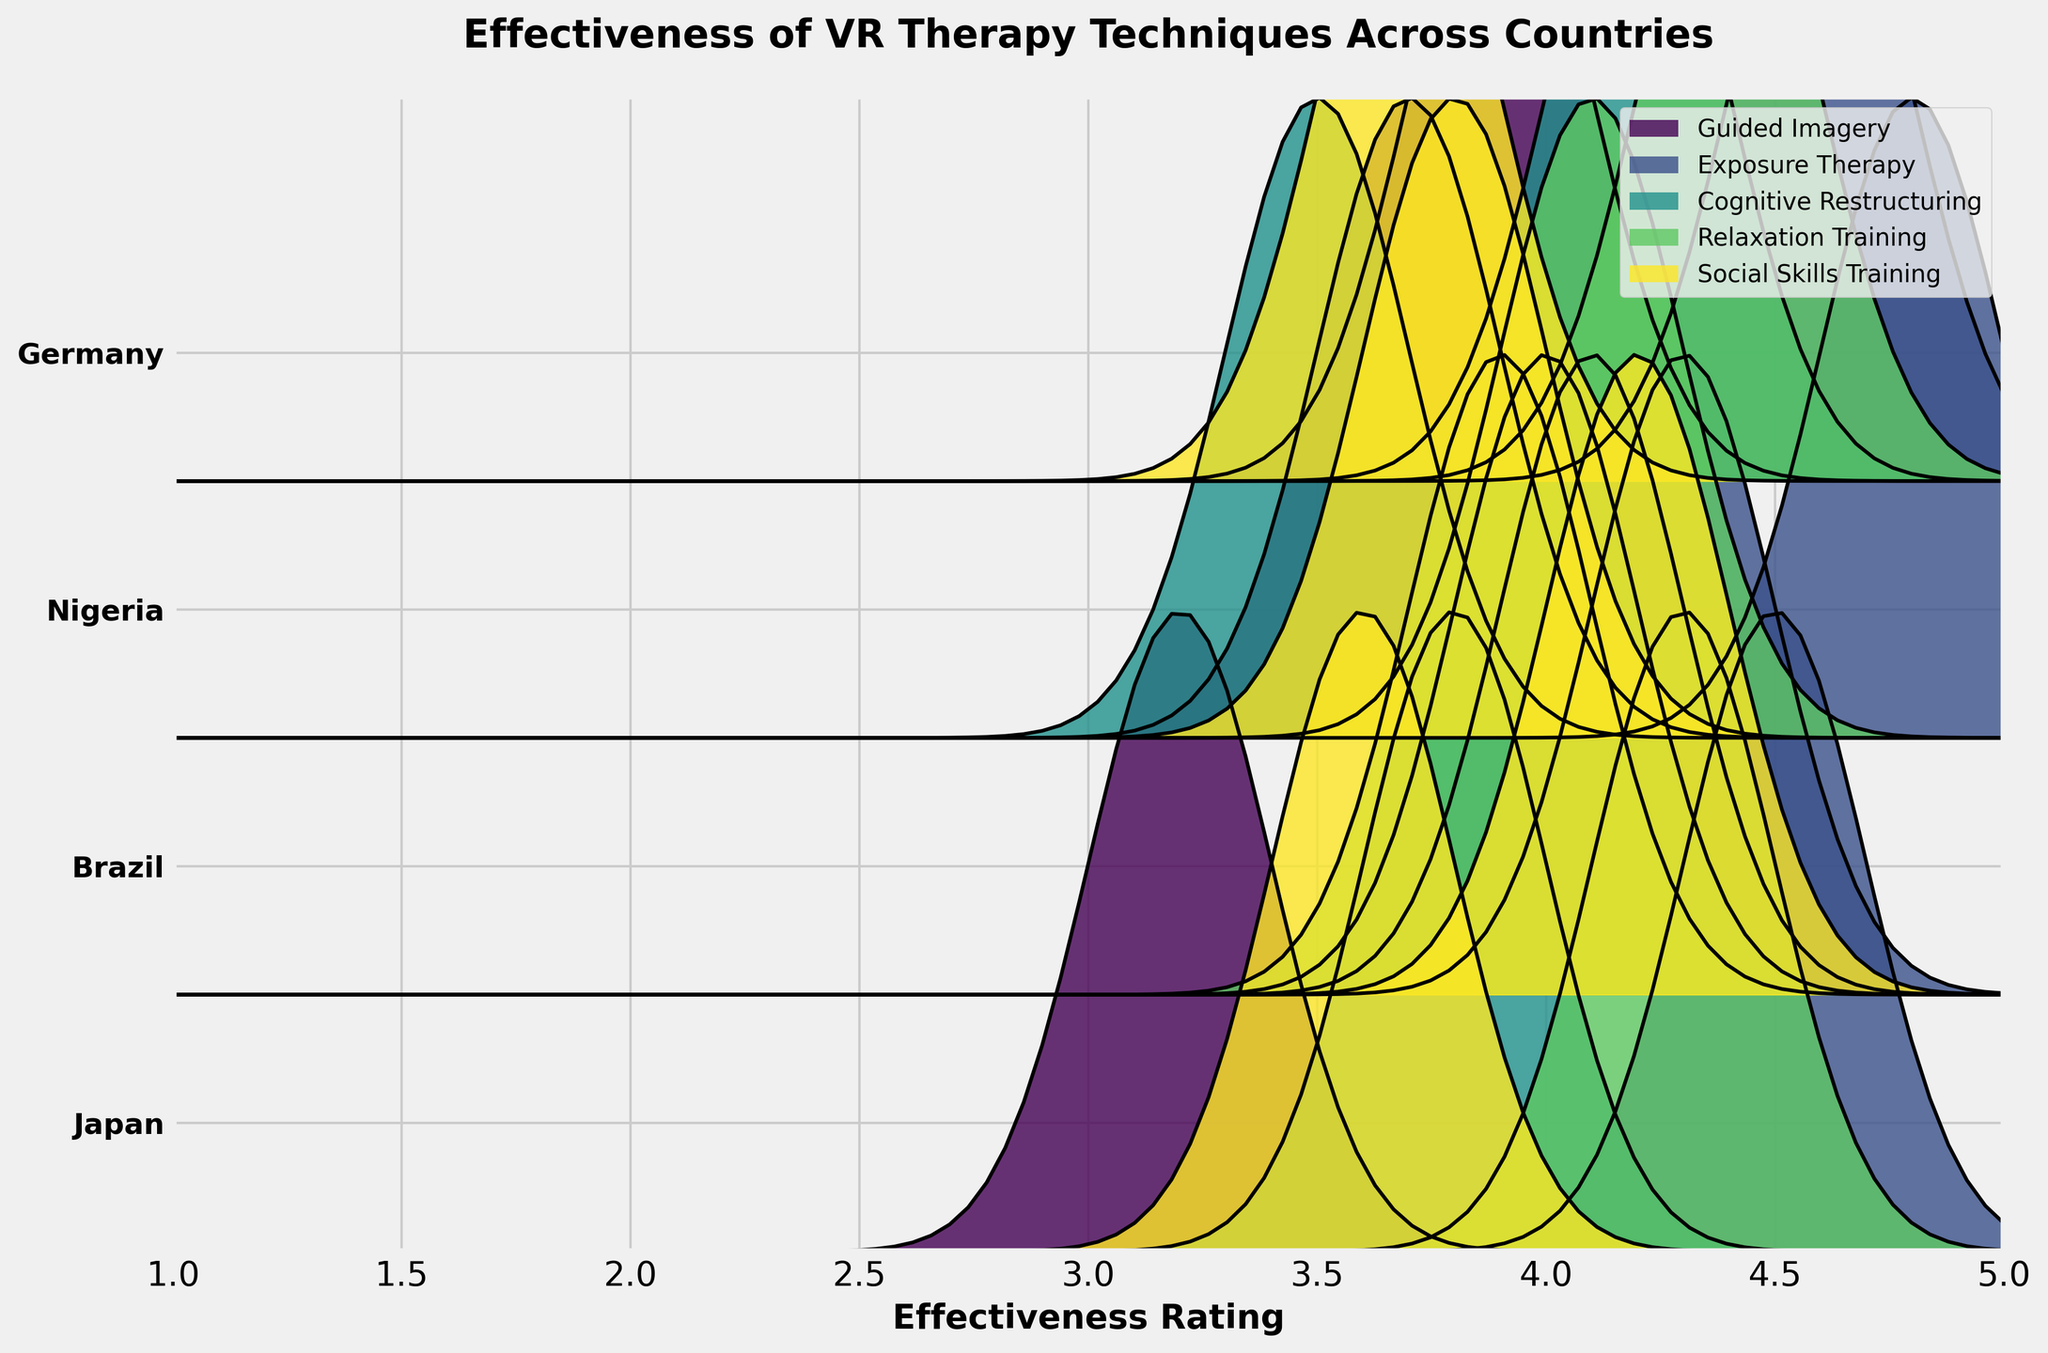What is the title of the plot? The title is always found at the top of the figure. Here, it is clearly visible in bold text.
Answer: Effectiveness of VR Therapy Techniques Across Countries What is the x-axis representing? The labels and title along the horizontal axis indicate what is being measured. Here, it says 'Effectiveness Rating'.
Answer: Effectiveness Rating How many VR therapy techniques are compared in the plot? Techniques can be identified by their unique fill colors and labels in the legend. Counting the legend entries gives us the number of techniques.
Answer: 5 Which country has the highest effectiveness rating for Exposure Therapy? Identify the curve labeled 'Exposure Therapy' and find the country corresponding to the highest peak.
Answer: Nigeria What is the effectiveness rating of Relaxation Training in Germany? Look for the curve labeled 'Relaxation Training' and identify the peak near the Germany label.
Answer: 4.4 Which VR therapy technique has the lowest effectiveness rating in Japan? Look through the curves aligned with Japan and find the one with the lowest peak value compared to the x-axis scale.
Answer: Guided Imagery What is the average effectiveness rating of Exposure Therapy across all countries? The effectiveness ratings for Exposure Therapy in different countries are 4.5, 4.3, 4.8, and 4.6. Add them together and divide by 4.
Answer: 4.55 Compare the effectiveness rating of Cognitive Restructuring between Brazil and Nigeria. Which country has a higher rating? Observe the Cognitive Restructuring curves aligned with Brazil and Nigeria, then compare their peaks.
Answer: Brazil How does Social Skills Training effectiveness in Brazil compare to Guided Imagery effectiveness in Germany? Locate the respective peaks for Social Skills Training in Brazil and Guided Imagery in Germany and compare which is higher.
Answer: Higher in Brazil for Social Skills Training Which therapy technique shows the most consistent effectiveness rating across all countries? Consistency can be assessed by observing the variability in the height of the peaks for each technique across different countries. The technique with the least variation is the most consistent.
Answer: Exposure Therapy 